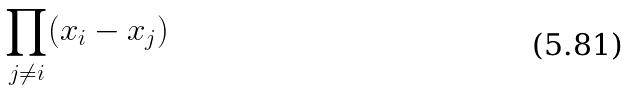<formula> <loc_0><loc_0><loc_500><loc_500>\prod _ { j \ne i } ( x _ { i } - x _ { j } )</formula> 